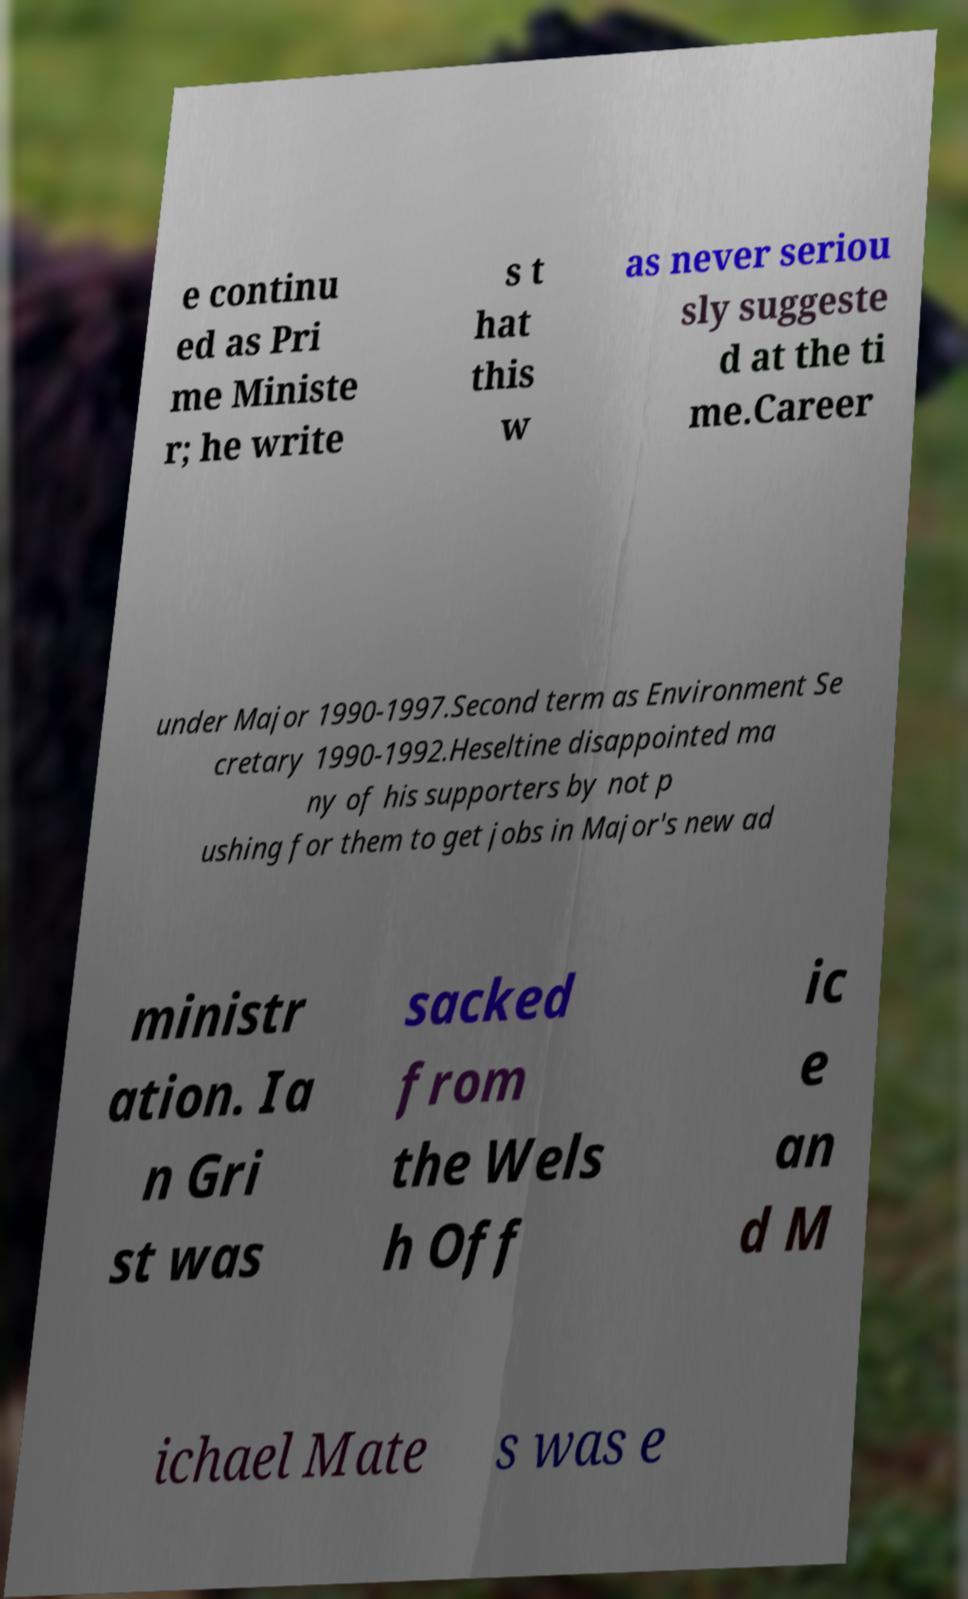What messages or text are displayed in this image? I need them in a readable, typed format. e continu ed as Pri me Ministe r; he write s t hat this w as never seriou sly suggeste d at the ti me.Career under Major 1990-1997.Second term as Environment Se cretary 1990-1992.Heseltine disappointed ma ny of his supporters by not p ushing for them to get jobs in Major's new ad ministr ation. Ia n Gri st was sacked from the Wels h Off ic e an d M ichael Mate s was e 